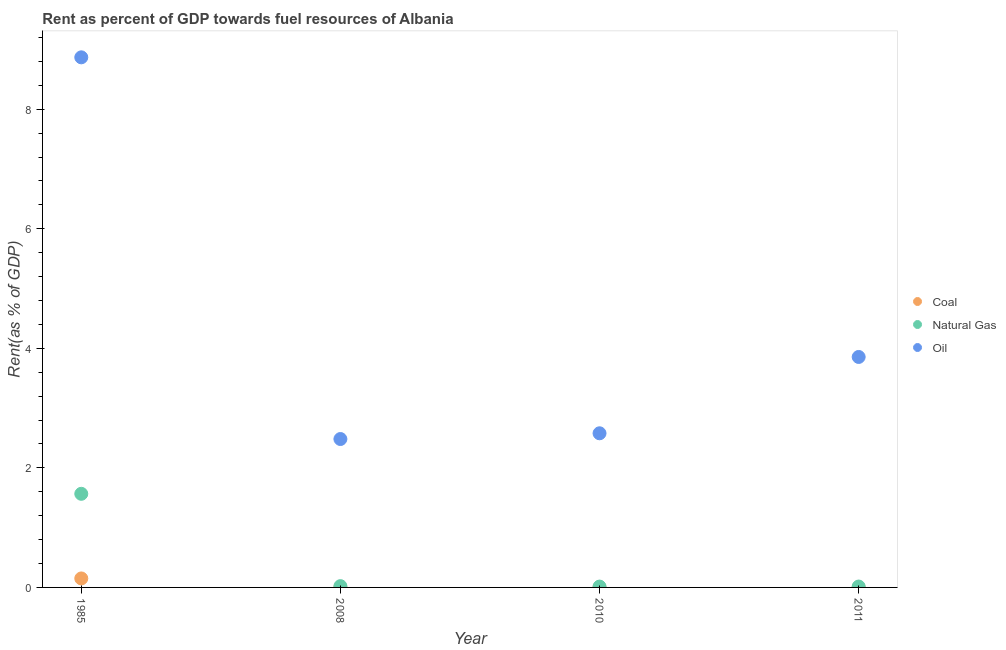What is the rent towards oil in 1985?
Keep it short and to the point. 8.87. Across all years, what is the maximum rent towards oil?
Offer a terse response. 8.87. Across all years, what is the minimum rent towards coal?
Offer a terse response. 0. In which year was the rent towards natural gas maximum?
Offer a very short reply. 1985. In which year was the rent towards natural gas minimum?
Give a very brief answer. 2010. What is the total rent towards coal in the graph?
Offer a very short reply. 0.15. What is the difference between the rent towards oil in 2008 and that in 2010?
Offer a terse response. -0.1. What is the difference between the rent towards oil in 1985 and the rent towards coal in 2010?
Make the answer very short. 8.87. What is the average rent towards oil per year?
Keep it short and to the point. 4.45. In the year 2011, what is the difference between the rent towards natural gas and rent towards oil?
Provide a succinct answer. -3.84. In how many years, is the rent towards oil greater than 5.2 %?
Ensure brevity in your answer.  1. What is the ratio of the rent towards oil in 1985 to that in 2008?
Your answer should be very brief. 3.57. Is the rent towards natural gas in 1985 less than that in 2010?
Offer a very short reply. No. What is the difference between the highest and the second highest rent towards natural gas?
Provide a succinct answer. 1.54. What is the difference between the highest and the lowest rent towards coal?
Offer a very short reply. 0.15. In how many years, is the rent towards oil greater than the average rent towards oil taken over all years?
Your answer should be compact. 1. Is the sum of the rent towards oil in 1985 and 2010 greater than the maximum rent towards natural gas across all years?
Provide a succinct answer. Yes. Is the rent towards coal strictly less than the rent towards oil over the years?
Give a very brief answer. Yes. How many dotlines are there?
Your response must be concise. 3. How many years are there in the graph?
Provide a short and direct response. 4. Are the values on the major ticks of Y-axis written in scientific E-notation?
Offer a terse response. No. Does the graph contain any zero values?
Keep it short and to the point. No. Does the graph contain grids?
Make the answer very short. No. How many legend labels are there?
Your response must be concise. 3. What is the title of the graph?
Keep it short and to the point. Rent as percent of GDP towards fuel resources of Albania. Does "Total employers" appear as one of the legend labels in the graph?
Ensure brevity in your answer.  No. What is the label or title of the X-axis?
Offer a terse response. Year. What is the label or title of the Y-axis?
Ensure brevity in your answer.  Rent(as % of GDP). What is the Rent(as % of GDP) in Coal in 1985?
Ensure brevity in your answer.  0.15. What is the Rent(as % of GDP) in Natural Gas in 1985?
Your answer should be compact. 1.57. What is the Rent(as % of GDP) in Oil in 1985?
Provide a short and direct response. 8.87. What is the Rent(as % of GDP) of Coal in 2008?
Your response must be concise. 0. What is the Rent(as % of GDP) of Natural Gas in 2008?
Make the answer very short. 0.02. What is the Rent(as % of GDP) in Oil in 2008?
Ensure brevity in your answer.  2.48. What is the Rent(as % of GDP) in Coal in 2010?
Your answer should be compact. 0. What is the Rent(as % of GDP) of Natural Gas in 2010?
Your answer should be compact. 0.01. What is the Rent(as % of GDP) of Oil in 2010?
Offer a very short reply. 2.58. What is the Rent(as % of GDP) in Coal in 2011?
Offer a terse response. 0. What is the Rent(as % of GDP) in Natural Gas in 2011?
Give a very brief answer. 0.01. What is the Rent(as % of GDP) of Oil in 2011?
Make the answer very short. 3.86. Across all years, what is the maximum Rent(as % of GDP) in Coal?
Keep it short and to the point. 0.15. Across all years, what is the maximum Rent(as % of GDP) in Natural Gas?
Make the answer very short. 1.57. Across all years, what is the maximum Rent(as % of GDP) in Oil?
Offer a very short reply. 8.87. Across all years, what is the minimum Rent(as % of GDP) in Coal?
Give a very brief answer. 0. Across all years, what is the minimum Rent(as % of GDP) in Natural Gas?
Keep it short and to the point. 0.01. Across all years, what is the minimum Rent(as % of GDP) of Oil?
Your answer should be compact. 2.48. What is the total Rent(as % of GDP) in Coal in the graph?
Keep it short and to the point. 0.15. What is the total Rent(as % of GDP) in Natural Gas in the graph?
Your answer should be very brief. 1.62. What is the total Rent(as % of GDP) in Oil in the graph?
Keep it short and to the point. 17.79. What is the difference between the Rent(as % of GDP) of Coal in 1985 and that in 2008?
Keep it short and to the point. 0.15. What is the difference between the Rent(as % of GDP) of Natural Gas in 1985 and that in 2008?
Provide a short and direct response. 1.54. What is the difference between the Rent(as % of GDP) of Oil in 1985 and that in 2008?
Your response must be concise. 6.39. What is the difference between the Rent(as % of GDP) in Coal in 1985 and that in 2010?
Your answer should be very brief. 0.15. What is the difference between the Rent(as % of GDP) in Natural Gas in 1985 and that in 2010?
Your answer should be compact. 1.55. What is the difference between the Rent(as % of GDP) in Oil in 1985 and that in 2010?
Offer a very short reply. 6.29. What is the difference between the Rent(as % of GDP) of Coal in 1985 and that in 2011?
Give a very brief answer. 0.15. What is the difference between the Rent(as % of GDP) in Natural Gas in 1985 and that in 2011?
Provide a succinct answer. 1.55. What is the difference between the Rent(as % of GDP) in Oil in 1985 and that in 2011?
Give a very brief answer. 5.01. What is the difference between the Rent(as % of GDP) of Coal in 2008 and that in 2010?
Make the answer very short. 0. What is the difference between the Rent(as % of GDP) in Natural Gas in 2008 and that in 2010?
Provide a succinct answer. 0.01. What is the difference between the Rent(as % of GDP) of Oil in 2008 and that in 2010?
Offer a very short reply. -0.1. What is the difference between the Rent(as % of GDP) in Coal in 2008 and that in 2011?
Offer a terse response. 0. What is the difference between the Rent(as % of GDP) in Natural Gas in 2008 and that in 2011?
Keep it short and to the point. 0.01. What is the difference between the Rent(as % of GDP) in Oil in 2008 and that in 2011?
Keep it short and to the point. -1.37. What is the difference between the Rent(as % of GDP) in Coal in 2010 and that in 2011?
Give a very brief answer. -0. What is the difference between the Rent(as % of GDP) of Natural Gas in 2010 and that in 2011?
Provide a short and direct response. -0. What is the difference between the Rent(as % of GDP) in Oil in 2010 and that in 2011?
Your answer should be compact. -1.28. What is the difference between the Rent(as % of GDP) of Coal in 1985 and the Rent(as % of GDP) of Natural Gas in 2008?
Offer a terse response. 0.13. What is the difference between the Rent(as % of GDP) of Coal in 1985 and the Rent(as % of GDP) of Oil in 2008?
Your answer should be very brief. -2.33. What is the difference between the Rent(as % of GDP) of Natural Gas in 1985 and the Rent(as % of GDP) of Oil in 2008?
Your answer should be very brief. -0.92. What is the difference between the Rent(as % of GDP) of Coal in 1985 and the Rent(as % of GDP) of Natural Gas in 2010?
Make the answer very short. 0.14. What is the difference between the Rent(as % of GDP) in Coal in 1985 and the Rent(as % of GDP) in Oil in 2010?
Offer a very short reply. -2.43. What is the difference between the Rent(as % of GDP) in Natural Gas in 1985 and the Rent(as % of GDP) in Oil in 2010?
Offer a very short reply. -1.01. What is the difference between the Rent(as % of GDP) of Coal in 1985 and the Rent(as % of GDP) of Natural Gas in 2011?
Offer a terse response. 0.14. What is the difference between the Rent(as % of GDP) of Coal in 1985 and the Rent(as % of GDP) of Oil in 2011?
Offer a terse response. -3.71. What is the difference between the Rent(as % of GDP) in Natural Gas in 1985 and the Rent(as % of GDP) in Oil in 2011?
Offer a very short reply. -2.29. What is the difference between the Rent(as % of GDP) in Coal in 2008 and the Rent(as % of GDP) in Natural Gas in 2010?
Ensure brevity in your answer.  -0.01. What is the difference between the Rent(as % of GDP) of Coal in 2008 and the Rent(as % of GDP) of Oil in 2010?
Your answer should be very brief. -2.58. What is the difference between the Rent(as % of GDP) of Natural Gas in 2008 and the Rent(as % of GDP) of Oil in 2010?
Your response must be concise. -2.56. What is the difference between the Rent(as % of GDP) of Coal in 2008 and the Rent(as % of GDP) of Natural Gas in 2011?
Give a very brief answer. -0.01. What is the difference between the Rent(as % of GDP) in Coal in 2008 and the Rent(as % of GDP) in Oil in 2011?
Your response must be concise. -3.85. What is the difference between the Rent(as % of GDP) of Natural Gas in 2008 and the Rent(as % of GDP) of Oil in 2011?
Your answer should be compact. -3.83. What is the difference between the Rent(as % of GDP) in Coal in 2010 and the Rent(as % of GDP) in Natural Gas in 2011?
Your answer should be compact. -0.01. What is the difference between the Rent(as % of GDP) of Coal in 2010 and the Rent(as % of GDP) of Oil in 2011?
Your response must be concise. -3.86. What is the difference between the Rent(as % of GDP) in Natural Gas in 2010 and the Rent(as % of GDP) in Oil in 2011?
Your response must be concise. -3.84. What is the average Rent(as % of GDP) in Coal per year?
Provide a succinct answer. 0.04. What is the average Rent(as % of GDP) in Natural Gas per year?
Make the answer very short. 0.4. What is the average Rent(as % of GDP) in Oil per year?
Offer a terse response. 4.45. In the year 1985, what is the difference between the Rent(as % of GDP) of Coal and Rent(as % of GDP) of Natural Gas?
Your response must be concise. -1.42. In the year 1985, what is the difference between the Rent(as % of GDP) in Coal and Rent(as % of GDP) in Oil?
Provide a succinct answer. -8.72. In the year 1985, what is the difference between the Rent(as % of GDP) in Natural Gas and Rent(as % of GDP) in Oil?
Keep it short and to the point. -7.3. In the year 2008, what is the difference between the Rent(as % of GDP) of Coal and Rent(as % of GDP) of Natural Gas?
Provide a succinct answer. -0.02. In the year 2008, what is the difference between the Rent(as % of GDP) of Coal and Rent(as % of GDP) of Oil?
Your answer should be very brief. -2.48. In the year 2008, what is the difference between the Rent(as % of GDP) of Natural Gas and Rent(as % of GDP) of Oil?
Your answer should be very brief. -2.46. In the year 2010, what is the difference between the Rent(as % of GDP) in Coal and Rent(as % of GDP) in Natural Gas?
Provide a short and direct response. -0.01. In the year 2010, what is the difference between the Rent(as % of GDP) of Coal and Rent(as % of GDP) of Oil?
Your response must be concise. -2.58. In the year 2010, what is the difference between the Rent(as % of GDP) in Natural Gas and Rent(as % of GDP) in Oil?
Ensure brevity in your answer.  -2.56. In the year 2011, what is the difference between the Rent(as % of GDP) in Coal and Rent(as % of GDP) in Natural Gas?
Provide a succinct answer. -0.01. In the year 2011, what is the difference between the Rent(as % of GDP) of Coal and Rent(as % of GDP) of Oil?
Ensure brevity in your answer.  -3.86. In the year 2011, what is the difference between the Rent(as % of GDP) of Natural Gas and Rent(as % of GDP) of Oil?
Give a very brief answer. -3.84. What is the ratio of the Rent(as % of GDP) in Coal in 1985 to that in 2008?
Give a very brief answer. 51.55. What is the ratio of the Rent(as % of GDP) of Natural Gas in 1985 to that in 2008?
Ensure brevity in your answer.  73.02. What is the ratio of the Rent(as % of GDP) of Oil in 1985 to that in 2008?
Offer a terse response. 3.57. What is the ratio of the Rent(as % of GDP) in Coal in 1985 to that in 2010?
Provide a short and direct response. 1196.46. What is the ratio of the Rent(as % of GDP) of Natural Gas in 1985 to that in 2010?
Make the answer very short. 110.78. What is the ratio of the Rent(as % of GDP) in Oil in 1985 to that in 2010?
Provide a short and direct response. 3.44. What is the ratio of the Rent(as % of GDP) in Coal in 1985 to that in 2011?
Offer a terse response. 593.21. What is the ratio of the Rent(as % of GDP) of Natural Gas in 1985 to that in 2011?
Provide a short and direct response. 106.22. What is the ratio of the Rent(as % of GDP) in Oil in 1985 to that in 2011?
Offer a terse response. 2.3. What is the ratio of the Rent(as % of GDP) of Coal in 2008 to that in 2010?
Provide a succinct answer. 23.21. What is the ratio of the Rent(as % of GDP) in Natural Gas in 2008 to that in 2010?
Your response must be concise. 1.52. What is the ratio of the Rent(as % of GDP) in Oil in 2008 to that in 2010?
Provide a succinct answer. 0.96. What is the ratio of the Rent(as % of GDP) of Coal in 2008 to that in 2011?
Keep it short and to the point. 11.51. What is the ratio of the Rent(as % of GDP) in Natural Gas in 2008 to that in 2011?
Offer a terse response. 1.45. What is the ratio of the Rent(as % of GDP) of Oil in 2008 to that in 2011?
Offer a terse response. 0.64. What is the ratio of the Rent(as % of GDP) in Coal in 2010 to that in 2011?
Provide a succinct answer. 0.5. What is the ratio of the Rent(as % of GDP) of Natural Gas in 2010 to that in 2011?
Offer a terse response. 0.96. What is the ratio of the Rent(as % of GDP) in Oil in 2010 to that in 2011?
Ensure brevity in your answer.  0.67. What is the difference between the highest and the second highest Rent(as % of GDP) in Coal?
Your answer should be very brief. 0.15. What is the difference between the highest and the second highest Rent(as % of GDP) of Natural Gas?
Your answer should be very brief. 1.54. What is the difference between the highest and the second highest Rent(as % of GDP) of Oil?
Make the answer very short. 5.01. What is the difference between the highest and the lowest Rent(as % of GDP) of Coal?
Offer a very short reply. 0.15. What is the difference between the highest and the lowest Rent(as % of GDP) in Natural Gas?
Your answer should be compact. 1.55. What is the difference between the highest and the lowest Rent(as % of GDP) of Oil?
Provide a short and direct response. 6.39. 